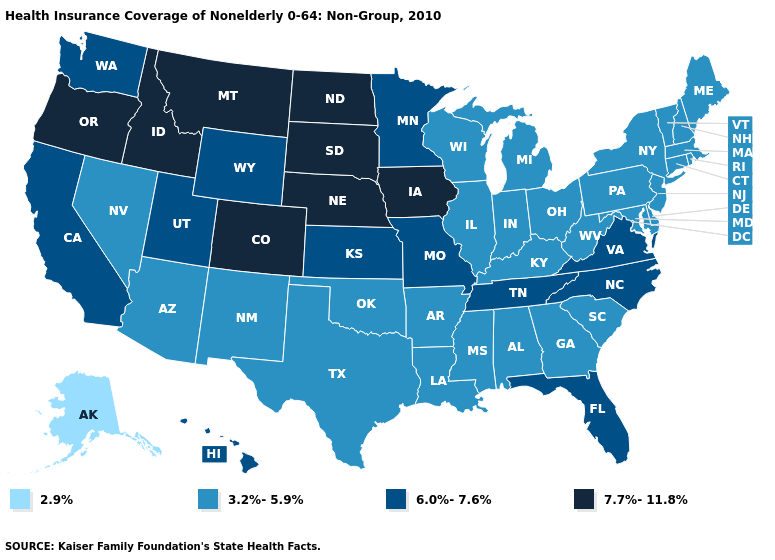What is the lowest value in the South?
Keep it brief. 3.2%-5.9%. What is the value of California?
Quick response, please. 6.0%-7.6%. Which states have the highest value in the USA?
Short answer required. Colorado, Idaho, Iowa, Montana, Nebraska, North Dakota, Oregon, South Dakota. What is the value of Montana?
Write a very short answer. 7.7%-11.8%. Among the states that border Nevada , which have the lowest value?
Write a very short answer. Arizona. Does Mississippi have the same value as Florida?
Write a very short answer. No. What is the value of Rhode Island?
Concise answer only. 3.2%-5.9%. What is the lowest value in the USA?
Keep it brief. 2.9%. Among the states that border California , which have the lowest value?
Short answer required. Arizona, Nevada. What is the lowest value in the Northeast?
Concise answer only. 3.2%-5.9%. Does Tennessee have the lowest value in the South?
Give a very brief answer. No. Which states have the lowest value in the USA?
Give a very brief answer. Alaska. Does Missouri have a lower value than Colorado?
Concise answer only. Yes. What is the value of Kentucky?
Concise answer only. 3.2%-5.9%. Name the states that have a value in the range 7.7%-11.8%?
Write a very short answer. Colorado, Idaho, Iowa, Montana, Nebraska, North Dakota, Oregon, South Dakota. 